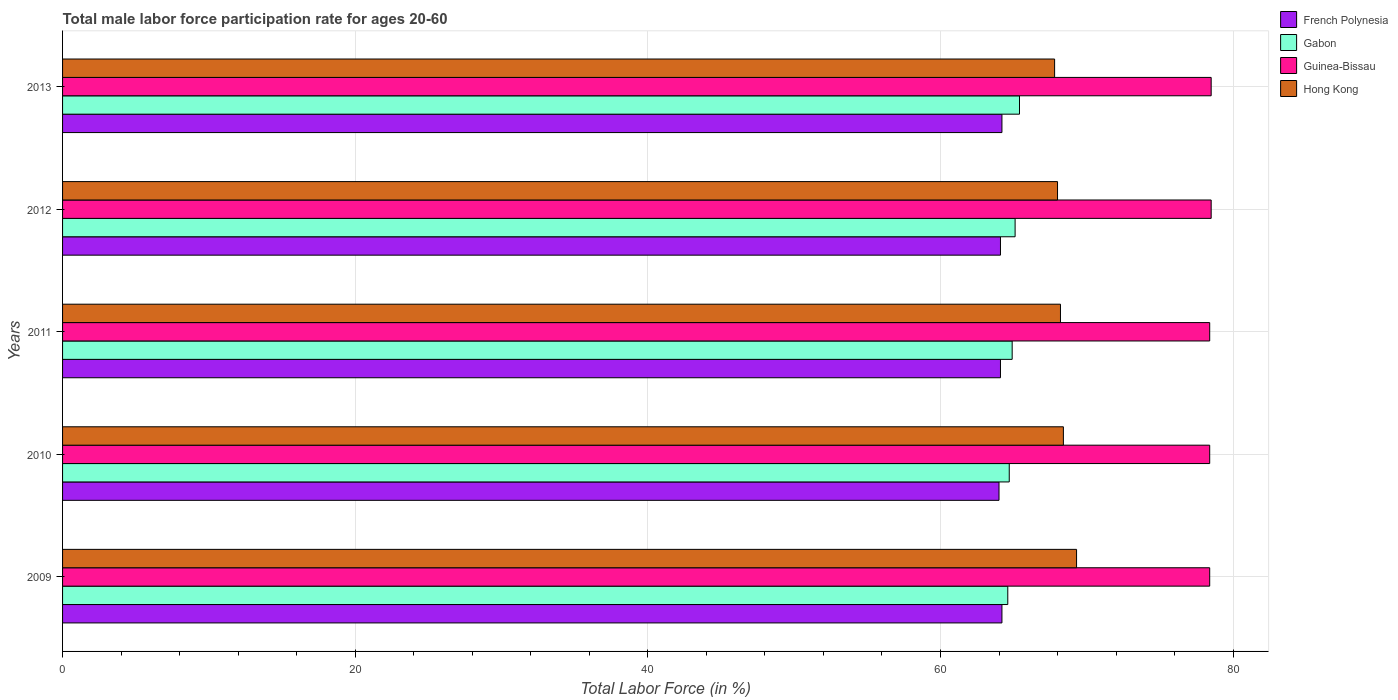How many groups of bars are there?
Make the answer very short. 5. How many bars are there on the 5th tick from the top?
Make the answer very short. 4. How many bars are there on the 1st tick from the bottom?
Ensure brevity in your answer.  4. What is the label of the 5th group of bars from the top?
Ensure brevity in your answer.  2009. What is the male labor force participation rate in Guinea-Bissau in 2013?
Your answer should be very brief. 78.5. Across all years, what is the maximum male labor force participation rate in Guinea-Bissau?
Provide a succinct answer. 78.5. Across all years, what is the minimum male labor force participation rate in French Polynesia?
Offer a very short reply. 64. In which year was the male labor force participation rate in Hong Kong maximum?
Your response must be concise. 2009. In which year was the male labor force participation rate in French Polynesia minimum?
Give a very brief answer. 2010. What is the total male labor force participation rate in French Polynesia in the graph?
Make the answer very short. 320.6. What is the difference between the male labor force participation rate in Guinea-Bissau in 2010 and that in 2013?
Ensure brevity in your answer.  -0.1. What is the difference between the male labor force participation rate in Guinea-Bissau in 2011 and the male labor force participation rate in Gabon in 2012?
Your answer should be compact. 13.3. What is the average male labor force participation rate in Hong Kong per year?
Offer a very short reply. 68.34. In the year 2010, what is the difference between the male labor force participation rate in Guinea-Bissau and male labor force participation rate in Hong Kong?
Keep it short and to the point. 10. In how many years, is the male labor force participation rate in Gabon greater than 52 %?
Your response must be concise. 5. What is the ratio of the male labor force participation rate in French Polynesia in 2010 to that in 2013?
Offer a terse response. 1. Is the male labor force participation rate in French Polynesia in 2009 less than that in 2013?
Offer a very short reply. No. Is the difference between the male labor force participation rate in Guinea-Bissau in 2010 and 2013 greater than the difference between the male labor force participation rate in Hong Kong in 2010 and 2013?
Your answer should be compact. No. What is the difference between the highest and the second highest male labor force participation rate in Guinea-Bissau?
Keep it short and to the point. 0. What is the difference between the highest and the lowest male labor force participation rate in Hong Kong?
Ensure brevity in your answer.  1.5. Is the sum of the male labor force participation rate in Hong Kong in 2010 and 2013 greater than the maximum male labor force participation rate in Gabon across all years?
Make the answer very short. Yes. Is it the case that in every year, the sum of the male labor force participation rate in Guinea-Bissau and male labor force participation rate in Hong Kong is greater than the sum of male labor force participation rate in Gabon and male labor force participation rate in French Polynesia?
Give a very brief answer. Yes. What does the 4th bar from the top in 2010 represents?
Offer a very short reply. French Polynesia. What does the 2nd bar from the bottom in 2012 represents?
Keep it short and to the point. Gabon. How many bars are there?
Give a very brief answer. 20. Are all the bars in the graph horizontal?
Your response must be concise. Yes. What is the difference between two consecutive major ticks on the X-axis?
Provide a short and direct response. 20. Are the values on the major ticks of X-axis written in scientific E-notation?
Give a very brief answer. No. Does the graph contain any zero values?
Provide a short and direct response. No. Does the graph contain grids?
Give a very brief answer. Yes. Where does the legend appear in the graph?
Give a very brief answer. Top right. How are the legend labels stacked?
Ensure brevity in your answer.  Vertical. What is the title of the graph?
Your response must be concise. Total male labor force participation rate for ages 20-60. Does "Low income" appear as one of the legend labels in the graph?
Offer a terse response. No. What is the label or title of the X-axis?
Ensure brevity in your answer.  Total Labor Force (in %). What is the Total Labor Force (in %) of French Polynesia in 2009?
Offer a terse response. 64.2. What is the Total Labor Force (in %) in Gabon in 2009?
Your answer should be very brief. 64.6. What is the Total Labor Force (in %) of Guinea-Bissau in 2009?
Provide a short and direct response. 78.4. What is the Total Labor Force (in %) in Hong Kong in 2009?
Keep it short and to the point. 69.3. What is the Total Labor Force (in %) of Gabon in 2010?
Keep it short and to the point. 64.7. What is the Total Labor Force (in %) of Guinea-Bissau in 2010?
Give a very brief answer. 78.4. What is the Total Labor Force (in %) of Hong Kong in 2010?
Keep it short and to the point. 68.4. What is the Total Labor Force (in %) in French Polynesia in 2011?
Provide a short and direct response. 64.1. What is the Total Labor Force (in %) in Gabon in 2011?
Provide a short and direct response. 64.9. What is the Total Labor Force (in %) of Guinea-Bissau in 2011?
Provide a succinct answer. 78.4. What is the Total Labor Force (in %) of Hong Kong in 2011?
Your response must be concise. 68.2. What is the Total Labor Force (in %) of French Polynesia in 2012?
Provide a short and direct response. 64.1. What is the Total Labor Force (in %) in Gabon in 2012?
Provide a short and direct response. 65.1. What is the Total Labor Force (in %) in Guinea-Bissau in 2012?
Your answer should be very brief. 78.5. What is the Total Labor Force (in %) in Hong Kong in 2012?
Your response must be concise. 68. What is the Total Labor Force (in %) of French Polynesia in 2013?
Give a very brief answer. 64.2. What is the Total Labor Force (in %) in Gabon in 2013?
Keep it short and to the point. 65.4. What is the Total Labor Force (in %) of Guinea-Bissau in 2013?
Provide a short and direct response. 78.5. What is the Total Labor Force (in %) of Hong Kong in 2013?
Offer a terse response. 67.8. Across all years, what is the maximum Total Labor Force (in %) of French Polynesia?
Provide a short and direct response. 64.2. Across all years, what is the maximum Total Labor Force (in %) of Gabon?
Keep it short and to the point. 65.4. Across all years, what is the maximum Total Labor Force (in %) in Guinea-Bissau?
Ensure brevity in your answer.  78.5. Across all years, what is the maximum Total Labor Force (in %) of Hong Kong?
Your response must be concise. 69.3. Across all years, what is the minimum Total Labor Force (in %) of French Polynesia?
Your answer should be compact. 64. Across all years, what is the minimum Total Labor Force (in %) in Gabon?
Make the answer very short. 64.6. Across all years, what is the minimum Total Labor Force (in %) of Guinea-Bissau?
Offer a very short reply. 78.4. Across all years, what is the minimum Total Labor Force (in %) in Hong Kong?
Offer a terse response. 67.8. What is the total Total Labor Force (in %) of French Polynesia in the graph?
Make the answer very short. 320.6. What is the total Total Labor Force (in %) in Gabon in the graph?
Keep it short and to the point. 324.7. What is the total Total Labor Force (in %) of Guinea-Bissau in the graph?
Ensure brevity in your answer.  392.2. What is the total Total Labor Force (in %) of Hong Kong in the graph?
Your answer should be compact. 341.7. What is the difference between the Total Labor Force (in %) of Gabon in 2009 and that in 2010?
Ensure brevity in your answer.  -0.1. What is the difference between the Total Labor Force (in %) in French Polynesia in 2009 and that in 2011?
Offer a terse response. 0.1. What is the difference between the Total Labor Force (in %) of Guinea-Bissau in 2009 and that in 2011?
Your answer should be very brief. 0. What is the difference between the Total Labor Force (in %) in French Polynesia in 2009 and that in 2012?
Keep it short and to the point. 0.1. What is the difference between the Total Labor Force (in %) in Gabon in 2009 and that in 2012?
Make the answer very short. -0.5. What is the difference between the Total Labor Force (in %) of Guinea-Bissau in 2009 and that in 2012?
Give a very brief answer. -0.1. What is the difference between the Total Labor Force (in %) in Gabon in 2009 and that in 2013?
Provide a succinct answer. -0.8. What is the difference between the Total Labor Force (in %) of Guinea-Bissau in 2009 and that in 2013?
Make the answer very short. -0.1. What is the difference between the Total Labor Force (in %) in French Polynesia in 2010 and that in 2011?
Keep it short and to the point. -0.1. What is the difference between the Total Labor Force (in %) in Hong Kong in 2010 and that in 2011?
Your response must be concise. 0.2. What is the difference between the Total Labor Force (in %) in French Polynesia in 2010 and that in 2012?
Offer a terse response. -0.1. What is the difference between the Total Labor Force (in %) of Guinea-Bissau in 2010 and that in 2012?
Your answer should be very brief. -0.1. What is the difference between the Total Labor Force (in %) in Hong Kong in 2010 and that in 2012?
Your response must be concise. 0.4. What is the difference between the Total Labor Force (in %) in French Polynesia in 2010 and that in 2013?
Your answer should be compact. -0.2. What is the difference between the Total Labor Force (in %) of Guinea-Bissau in 2010 and that in 2013?
Your answer should be very brief. -0.1. What is the difference between the Total Labor Force (in %) in Hong Kong in 2011 and that in 2012?
Keep it short and to the point. 0.2. What is the difference between the Total Labor Force (in %) in French Polynesia in 2011 and that in 2013?
Your answer should be compact. -0.1. What is the difference between the Total Labor Force (in %) of Guinea-Bissau in 2011 and that in 2013?
Keep it short and to the point. -0.1. What is the difference between the Total Labor Force (in %) of Hong Kong in 2011 and that in 2013?
Make the answer very short. 0.4. What is the difference between the Total Labor Force (in %) in French Polynesia in 2012 and that in 2013?
Offer a terse response. -0.1. What is the difference between the Total Labor Force (in %) in Gabon in 2012 and that in 2013?
Give a very brief answer. -0.3. What is the difference between the Total Labor Force (in %) of Guinea-Bissau in 2012 and that in 2013?
Your answer should be very brief. 0. What is the difference between the Total Labor Force (in %) of Hong Kong in 2012 and that in 2013?
Keep it short and to the point. 0.2. What is the difference between the Total Labor Force (in %) in French Polynesia in 2009 and the Total Labor Force (in %) in Gabon in 2010?
Give a very brief answer. -0.5. What is the difference between the Total Labor Force (in %) in French Polynesia in 2009 and the Total Labor Force (in %) in Guinea-Bissau in 2010?
Provide a short and direct response. -14.2. What is the difference between the Total Labor Force (in %) of Gabon in 2009 and the Total Labor Force (in %) of Guinea-Bissau in 2010?
Your answer should be very brief. -13.8. What is the difference between the Total Labor Force (in %) of Gabon in 2009 and the Total Labor Force (in %) of Hong Kong in 2010?
Your answer should be compact. -3.8. What is the difference between the Total Labor Force (in %) of Guinea-Bissau in 2009 and the Total Labor Force (in %) of Hong Kong in 2010?
Offer a terse response. 10. What is the difference between the Total Labor Force (in %) in French Polynesia in 2009 and the Total Labor Force (in %) in Guinea-Bissau in 2011?
Provide a succinct answer. -14.2. What is the difference between the Total Labor Force (in %) of Gabon in 2009 and the Total Labor Force (in %) of Hong Kong in 2011?
Give a very brief answer. -3.6. What is the difference between the Total Labor Force (in %) in Guinea-Bissau in 2009 and the Total Labor Force (in %) in Hong Kong in 2011?
Make the answer very short. 10.2. What is the difference between the Total Labor Force (in %) in French Polynesia in 2009 and the Total Labor Force (in %) in Gabon in 2012?
Offer a terse response. -0.9. What is the difference between the Total Labor Force (in %) in French Polynesia in 2009 and the Total Labor Force (in %) in Guinea-Bissau in 2012?
Give a very brief answer. -14.3. What is the difference between the Total Labor Force (in %) in French Polynesia in 2009 and the Total Labor Force (in %) in Hong Kong in 2012?
Ensure brevity in your answer.  -3.8. What is the difference between the Total Labor Force (in %) of Guinea-Bissau in 2009 and the Total Labor Force (in %) of Hong Kong in 2012?
Give a very brief answer. 10.4. What is the difference between the Total Labor Force (in %) in French Polynesia in 2009 and the Total Labor Force (in %) in Gabon in 2013?
Keep it short and to the point. -1.2. What is the difference between the Total Labor Force (in %) of French Polynesia in 2009 and the Total Labor Force (in %) of Guinea-Bissau in 2013?
Offer a terse response. -14.3. What is the difference between the Total Labor Force (in %) in French Polynesia in 2009 and the Total Labor Force (in %) in Hong Kong in 2013?
Provide a succinct answer. -3.6. What is the difference between the Total Labor Force (in %) of Gabon in 2009 and the Total Labor Force (in %) of Guinea-Bissau in 2013?
Your answer should be compact. -13.9. What is the difference between the Total Labor Force (in %) of Gabon in 2009 and the Total Labor Force (in %) of Hong Kong in 2013?
Provide a succinct answer. -3.2. What is the difference between the Total Labor Force (in %) in Guinea-Bissau in 2009 and the Total Labor Force (in %) in Hong Kong in 2013?
Keep it short and to the point. 10.6. What is the difference between the Total Labor Force (in %) of French Polynesia in 2010 and the Total Labor Force (in %) of Gabon in 2011?
Your answer should be compact. -0.9. What is the difference between the Total Labor Force (in %) of French Polynesia in 2010 and the Total Labor Force (in %) of Guinea-Bissau in 2011?
Make the answer very short. -14.4. What is the difference between the Total Labor Force (in %) of Gabon in 2010 and the Total Labor Force (in %) of Guinea-Bissau in 2011?
Your answer should be compact. -13.7. What is the difference between the Total Labor Force (in %) of Guinea-Bissau in 2010 and the Total Labor Force (in %) of Hong Kong in 2011?
Ensure brevity in your answer.  10.2. What is the difference between the Total Labor Force (in %) in Gabon in 2010 and the Total Labor Force (in %) in Guinea-Bissau in 2012?
Keep it short and to the point. -13.8. What is the difference between the Total Labor Force (in %) in French Polynesia in 2010 and the Total Labor Force (in %) in Gabon in 2013?
Offer a terse response. -1.4. What is the difference between the Total Labor Force (in %) in French Polynesia in 2010 and the Total Labor Force (in %) in Hong Kong in 2013?
Provide a succinct answer. -3.8. What is the difference between the Total Labor Force (in %) in Gabon in 2010 and the Total Labor Force (in %) in Guinea-Bissau in 2013?
Provide a short and direct response. -13.8. What is the difference between the Total Labor Force (in %) in French Polynesia in 2011 and the Total Labor Force (in %) in Guinea-Bissau in 2012?
Give a very brief answer. -14.4. What is the difference between the Total Labor Force (in %) in Gabon in 2011 and the Total Labor Force (in %) in Hong Kong in 2012?
Keep it short and to the point. -3.1. What is the difference between the Total Labor Force (in %) in French Polynesia in 2011 and the Total Labor Force (in %) in Gabon in 2013?
Your answer should be compact. -1.3. What is the difference between the Total Labor Force (in %) of French Polynesia in 2011 and the Total Labor Force (in %) of Guinea-Bissau in 2013?
Give a very brief answer. -14.4. What is the difference between the Total Labor Force (in %) in Gabon in 2011 and the Total Labor Force (in %) in Hong Kong in 2013?
Offer a terse response. -2.9. What is the difference between the Total Labor Force (in %) of Guinea-Bissau in 2011 and the Total Labor Force (in %) of Hong Kong in 2013?
Give a very brief answer. 10.6. What is the difference between the Total Labor Force (in %) of French Polynesia in 2012 and the Total Labor Force (in %) of Gabon in 2013?
Your response must be concise. -1.3. What is the difference between the Total Labor Force (in %) of French Polynesia in 2012 and the Total Labor Force (in %) of Guinea-Bissau in 2013?
Provide a succinct answer. -14.4. What is the average Total Labor Force (in %) of French Polynesia per year?
Your response must be concise. 64.12. What is the average Total Labor Force (in %) in Gabon per year?
Ensure brevity in your answer.  64.94. What is the average Total Labor Force (in %) of Guinea-Bissau per year?
Offer a terse response. 78.44. What is the average Total Labor Force (in %) in Hong Kong per year?
Provide a short and direct response. 68.34. In the year 2009, what is the difference between the Total Labor Force (in %) in French Polynesia and Total Labor Force (in %) in Gabon?
Give a very brief answer. -0.4. In the year 2009, what is the difference between the Total Labor Force (in %) in French Polynesia and Total Labor Force (in %) in Guinea-Bissau?
Keep it short and to the point. -14.2. In the year 2009, what is the difference between the Total Labor Force (in %) in French Polynesia and Total Labor Force (in %) in Hong Kong?
Keep it short and to the point. -5.1. In the year 2009, what is the difference between the Total Labor Force (in %) in Gabon and Total Labor Force (in %) in Guinea-Bissau?
Offer a terse response. -13.8. In the year 2009, what is the difference between the Total Labor Force (in %) in Gabon and Total Labor Force (in %) in Hong Kong?
Provide a succinct answer. -4.7. In the year 2009, what is the difference between the Total Labor Force (in %) in Guinea-Bissau and Total Labor Force (in %) in Hong Kong?
Offer a very short reply. 9.1. In the year 2010, what is the difference between the Total Labor Force (in %) of French Polynesia and Total Labor Force (in %) of Gabon?
Provide a succinct answer. -0.7. In the year 2010, what is the difference between the Total Labor Force (in %) of French Polynesia and Total Labor Force (in %) of Guinea-Bissau?
Keep it short and to the point. -14.4. In the year 2010, what is the difference between the Total Labor Force (in %) of French Polynesia and Total Labor Force (in %) of Hong Kong?
Keep it short and to the point. -4.4. In the year 2010, what is the difference between the Total Labor Force (in %) of Gabon and Total Labor Force (in %) of Guinea-Bissau?
Give a very brief answer. -13.7. In the year 2011, what is the difference between the Total Labor Force (in %) in French Polynesia and Total Labor Force (in %) in Gabon?
Give a very brief answer. -0.8. In the year 2011, what is the difference between the Total Labor Force (in %) in French Polynesia and Total Labor Force (in %) in Guinea-Bissau?
Your answer should be compact. -14.3. In the year 2011, what is the difference between the Total Labor Force (in %) of Gabon and Total Labor Force (in %) of Guinea-Bissau?
Provide a succinct answer. -13.5. In the year 2011, what is the difference between the Total Labor Force (in %) in Guinea-Bissau and Total Labor Force (in %) in Hong Kong?
Your answer should be very brief. 10.2. In the year 2012, what is the difference between the Total Labor Force (in %) of French Polynesia and Total Labor Force (in %) of Guinea-Bissau?
Offer a very short reply. -14.4. In the year 2013, what is the difference between the Total Labor Force (in %) of French Polynesia and Total Labor Force (in %) of Guinea-Bissau?
Ensure brevity in your answer.  -14.3. In the year 2013, what is the difference between the Total Labor Force (in %) in Gabon and Total Labor Force (in %) in Hong Kong?
Provide a succinct answer. -2.4. What is the ratio of the Total Labor Force (in %) in French Polynesia in 2009 to that in 2010?
Your answer should be very brief. 1. What is the ratio of the Total Labor Force (in %) in Hong Kong in 2009 to that in 2010?
Provide a succinct answer. 1.01. What is the ratio of the Total Labor Force (in %) in French Polynesia in 2009 to that in 2011?
Your answer should be compact. 1. What is the ratio of the Total Labor Force (in %) of Gabon in 2009 to that in 2011?
Give a very brief answer. 1. What is the ratio of the Total Labor Force (in %) in Guinea-Bissau in 2009 to that in 2011?
Ensure brevity in your answer.  1. What is the ratio of the Total Labor Force (in %) of Hong Kong in 2009 to that in 2011?
Give a very brief answer. 1.02. What is the ratio of the Total Labor Force (in %) in Gabon in 2009 to that in 2012?
Offer a very short reply. 0.99. What is the ratio of the Total Labor Force (in %) of Guinea-Bissau in 2009 to that in 2012?
Offer a terse response. 1. What is the ratio of the Total Labor Force (in %) in Hong Kong in 2009 to that in 2012?
Your response must be concise. 1.02. What is the ratio of the Total Labor Force (in %) of French Polynesia in 2009 to that in 2013?
Provide a succinct answer. 1. What is the ratio of the Total Labor Force (in %) of Guinea-Bissau in 2009 to that in 2013?
Your answer should be compact. 1. What is the ratio of the Total Labor Force (in %) in Hong Kong in 2009 to that in 2013?
Your answer should be very brief. 1.02. What is the ratio of the Total Labor Force (in %) in French Polynesia in 2010 to that in 2011?
Provide a succinct answer. 1. What is the ratio of the Total Labor Force (in %) in Guinea-Bissau in 2010 to that in 2011?
Keep it short and to the point. 1. What is the ratio of the Total Labor Force (in %) in Hong Kong in 2010 to that in 2011?
Keep it short and to the point. 1. What is the ratio of the Total Labor Force (in %) of Gabon in 2010 to that in 2012?
Provide a short and direct response. 0.99. What is the ratio of the Total Labor Force (in %) in Hong Kong in 2010 to that in 2012?
Your response must be concise. 1.01. What is the ratio of the Total Labor Force (in %) in Gabon in 2010 to that in 2013?
Offer a very short reply. 0.99. What is the ratio of the Total Labor Force (in %) in Guinea-Bissau in 2010 to that in 2013?
Your answer should be very brief. 1. What is the ratio of the Total Labor Force (in %) in Hong Kong in 2010 to that in 2013?
Offer a terse response. 1.01. What is the ratio of the Total Labor Force (in %) of Guinea-Bissau in 2011 to that in 2012?
Your answer should be compact. 1. What is the ratio of the Total Labor Force (in %) in Hong Kong in 2011 to that in 2012?
Your answer should be compact. 1. What is the ratio of the Total Labor Force (in %) of French Polynesia in 2011 to that in 2013?
Ensure brevity in your answer.  1. What is the ratio of the Total Labor Force (in %) of Hong Kong in 2011 to that in 2013?
Provide a succinct answer. 1.01. What is the ratio of the Total Labor Force (in %) in Gabon in 2012 to that in 2013?
Your response must be concise. 1. What is the difference between the highest and the second highest Total Labor Force (in %) of French Polynesia?
Keep it short and to the point. 0. What is the difference between the highest and the second highest Total Labor Force (in %) in Gabon?
Make the answer very short. 0.3. What is the difference between the highest and the second highest Total Labor Force (in %) in Hong Kong?
Give a very brief answer. 0.9. What is the difference between the highest and the lowest Total Labor Force (in %) of Gabon?
Your response must be concise. 0.8. What is the difference between the highest and the lowest Total Labor Force (in %) of Guinea-Bissau?
Offer a terse response. 0.1. 